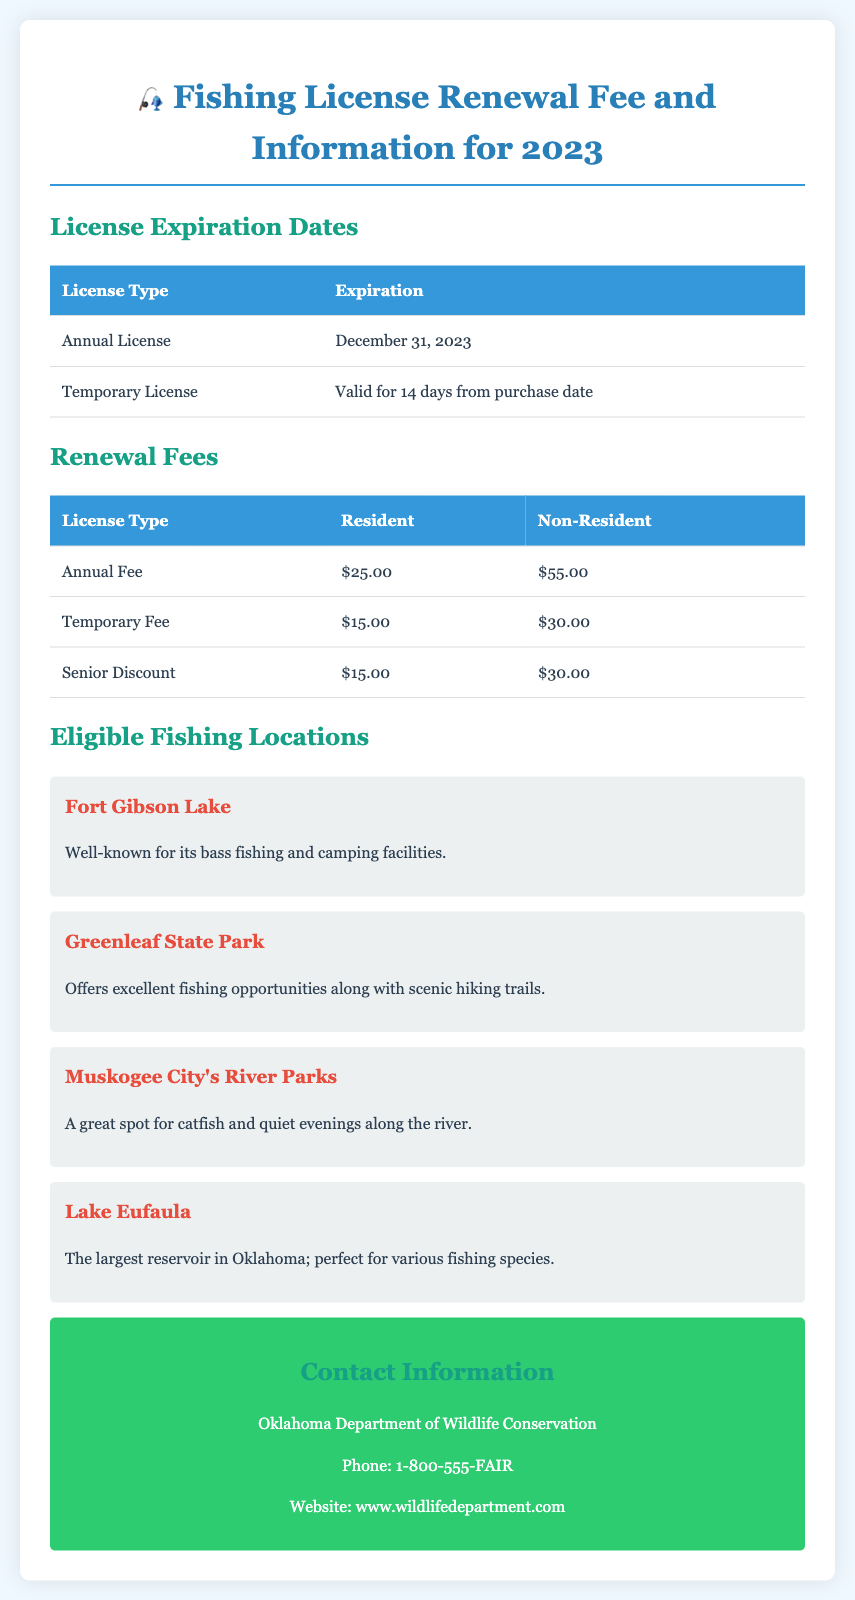What is the expiration date for the Annual License? The expiration date for the Annual License is noted in the document as December 31, 2023.
Answer: December 31, 2023 What is the fee for a Non-Resident Annual License? The document states that the fee for a Non-Resident Annual License is $55.00.
Answer: $55.00 How long is a Temporary License valid? According to the information, a Temporary License is valid for 14 days from the purchase date.
Answer: 14 days Which fishing location is well-known for its bass fishing? The document specifies that Fort Gibson Lake is well-known for its bass fishing.
Answer: Fort Gibson Lake What is the fee for a Resident Senior Discount License? The bill states that the fee for a Resident Senior Discount License is $15.00.
Answer: $15.00 What fishing location is described as perfect for various fishing species? The document mentions that Lake Eufaula is perfect for various fishing species.
Answer: Lake Eufaula What organization is responsible for fishing license information? The document lists the Oklahoma Department of Wildlife Conservation as responsible for fishing license information.
Answer: Oklahoma Department of Wildlife Conservation Which fishing location offers scenic hiking trails? Greenleaf State Park is indicated in the document as offering excellent fishing opportunities along with scenic hiking trails.
Answer: Greenleaf State Park 